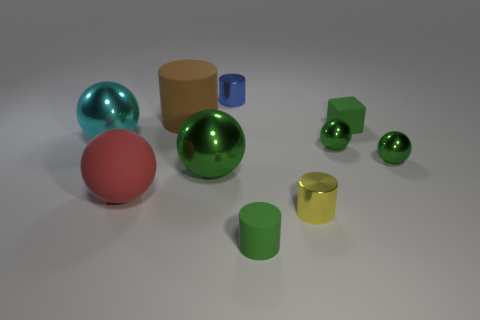Subtract all gray cylinders. How many green spheres are left? 3 Subtract all big brown cylinders. How many cylinders are left? 3 Subtract all red balls. How many balls are left? 4 Subtract 1 cylinders. How many cylinders are left? 3 Subtract all gray cylinders. Subtract all cyan spheres. How many cylinders are left? 4 Subtract 0 purple cubes. How many objects are left? 10 Subtract all blocks. How many objects are left? 9 Subtract all big cyan metal things. Subtract all big cyan shiny spheres. How many objects are left? 8 Add 8 green cubes. How many green cubes are left? 9 Add 7 small green cylinders. How many small green cylinders exist? 8 